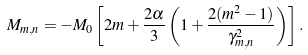Convert formula to latex. <formula><loc_0><loc_0><loc_500><loc_500>M _ { m , n } = - M _ { 0 } \left [ 2 m + \frac { 2 \alpha } { 3 } \left ( 1 + \frac { 2 ( m ^ { 2 } - 1 ) } { \gamma _ { m , n } ^ { 2 } } \right ) \right ] .</formula> 